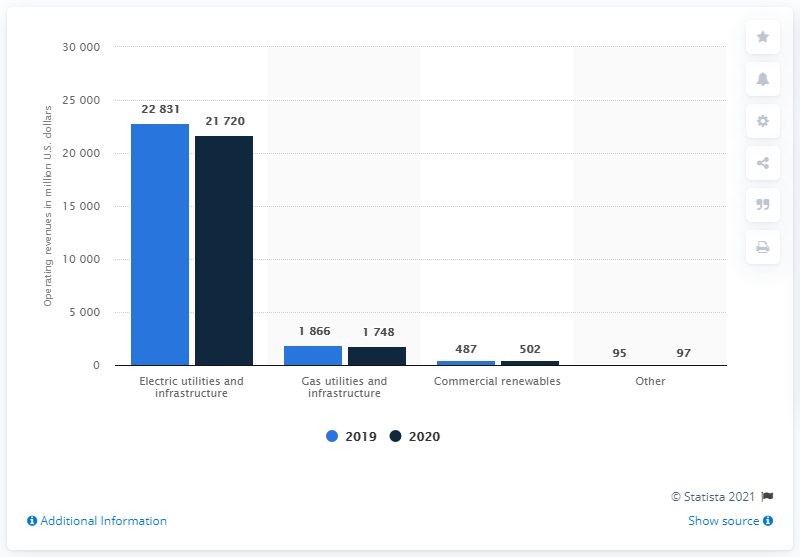Outline some significant characteristics in this image. In the fiscal year 2020, Duke Energy's operating revenue was approximately 21,720. 